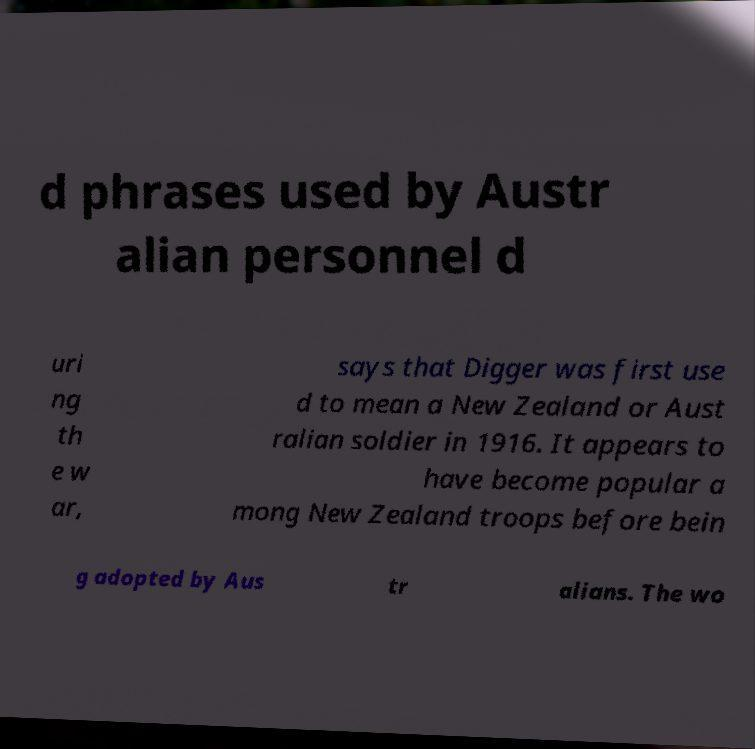Can you accurately transcribe the text from the provided image for me? d phrases used by Austr alian personnel d uri ng th e w ar, says that Digger was first use d to mean a New Zealand or Aust ralian soldier in 1916. It appears to have become popular a mong New Zealand troops before bein g adopted by Aus tr alians. The wo 